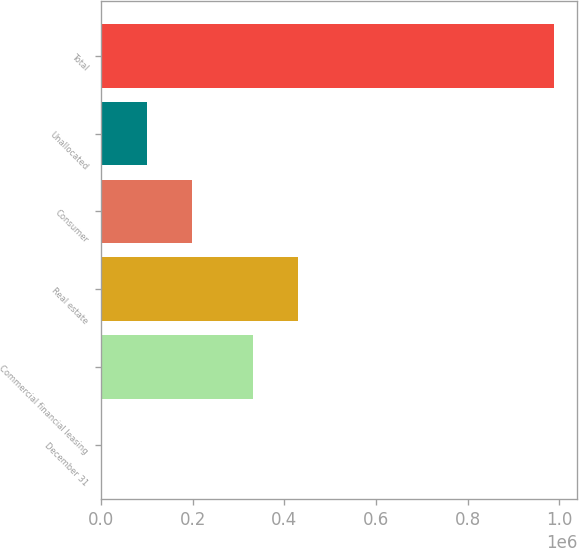Convert chart to OTSL. <chart><loc_0><loc_0><loc_500><loc_500><bar_chart><fcel>December 31<fcel>Commercial financial leasing<fcel>Real estate<fcel>Consumer<fcel>Unallocated<fcel>Total<nl><fcel>2016<fcel>330833<fcel>429531<fcel>199412<fcel>100714<fcel>988997<nl></chart> 